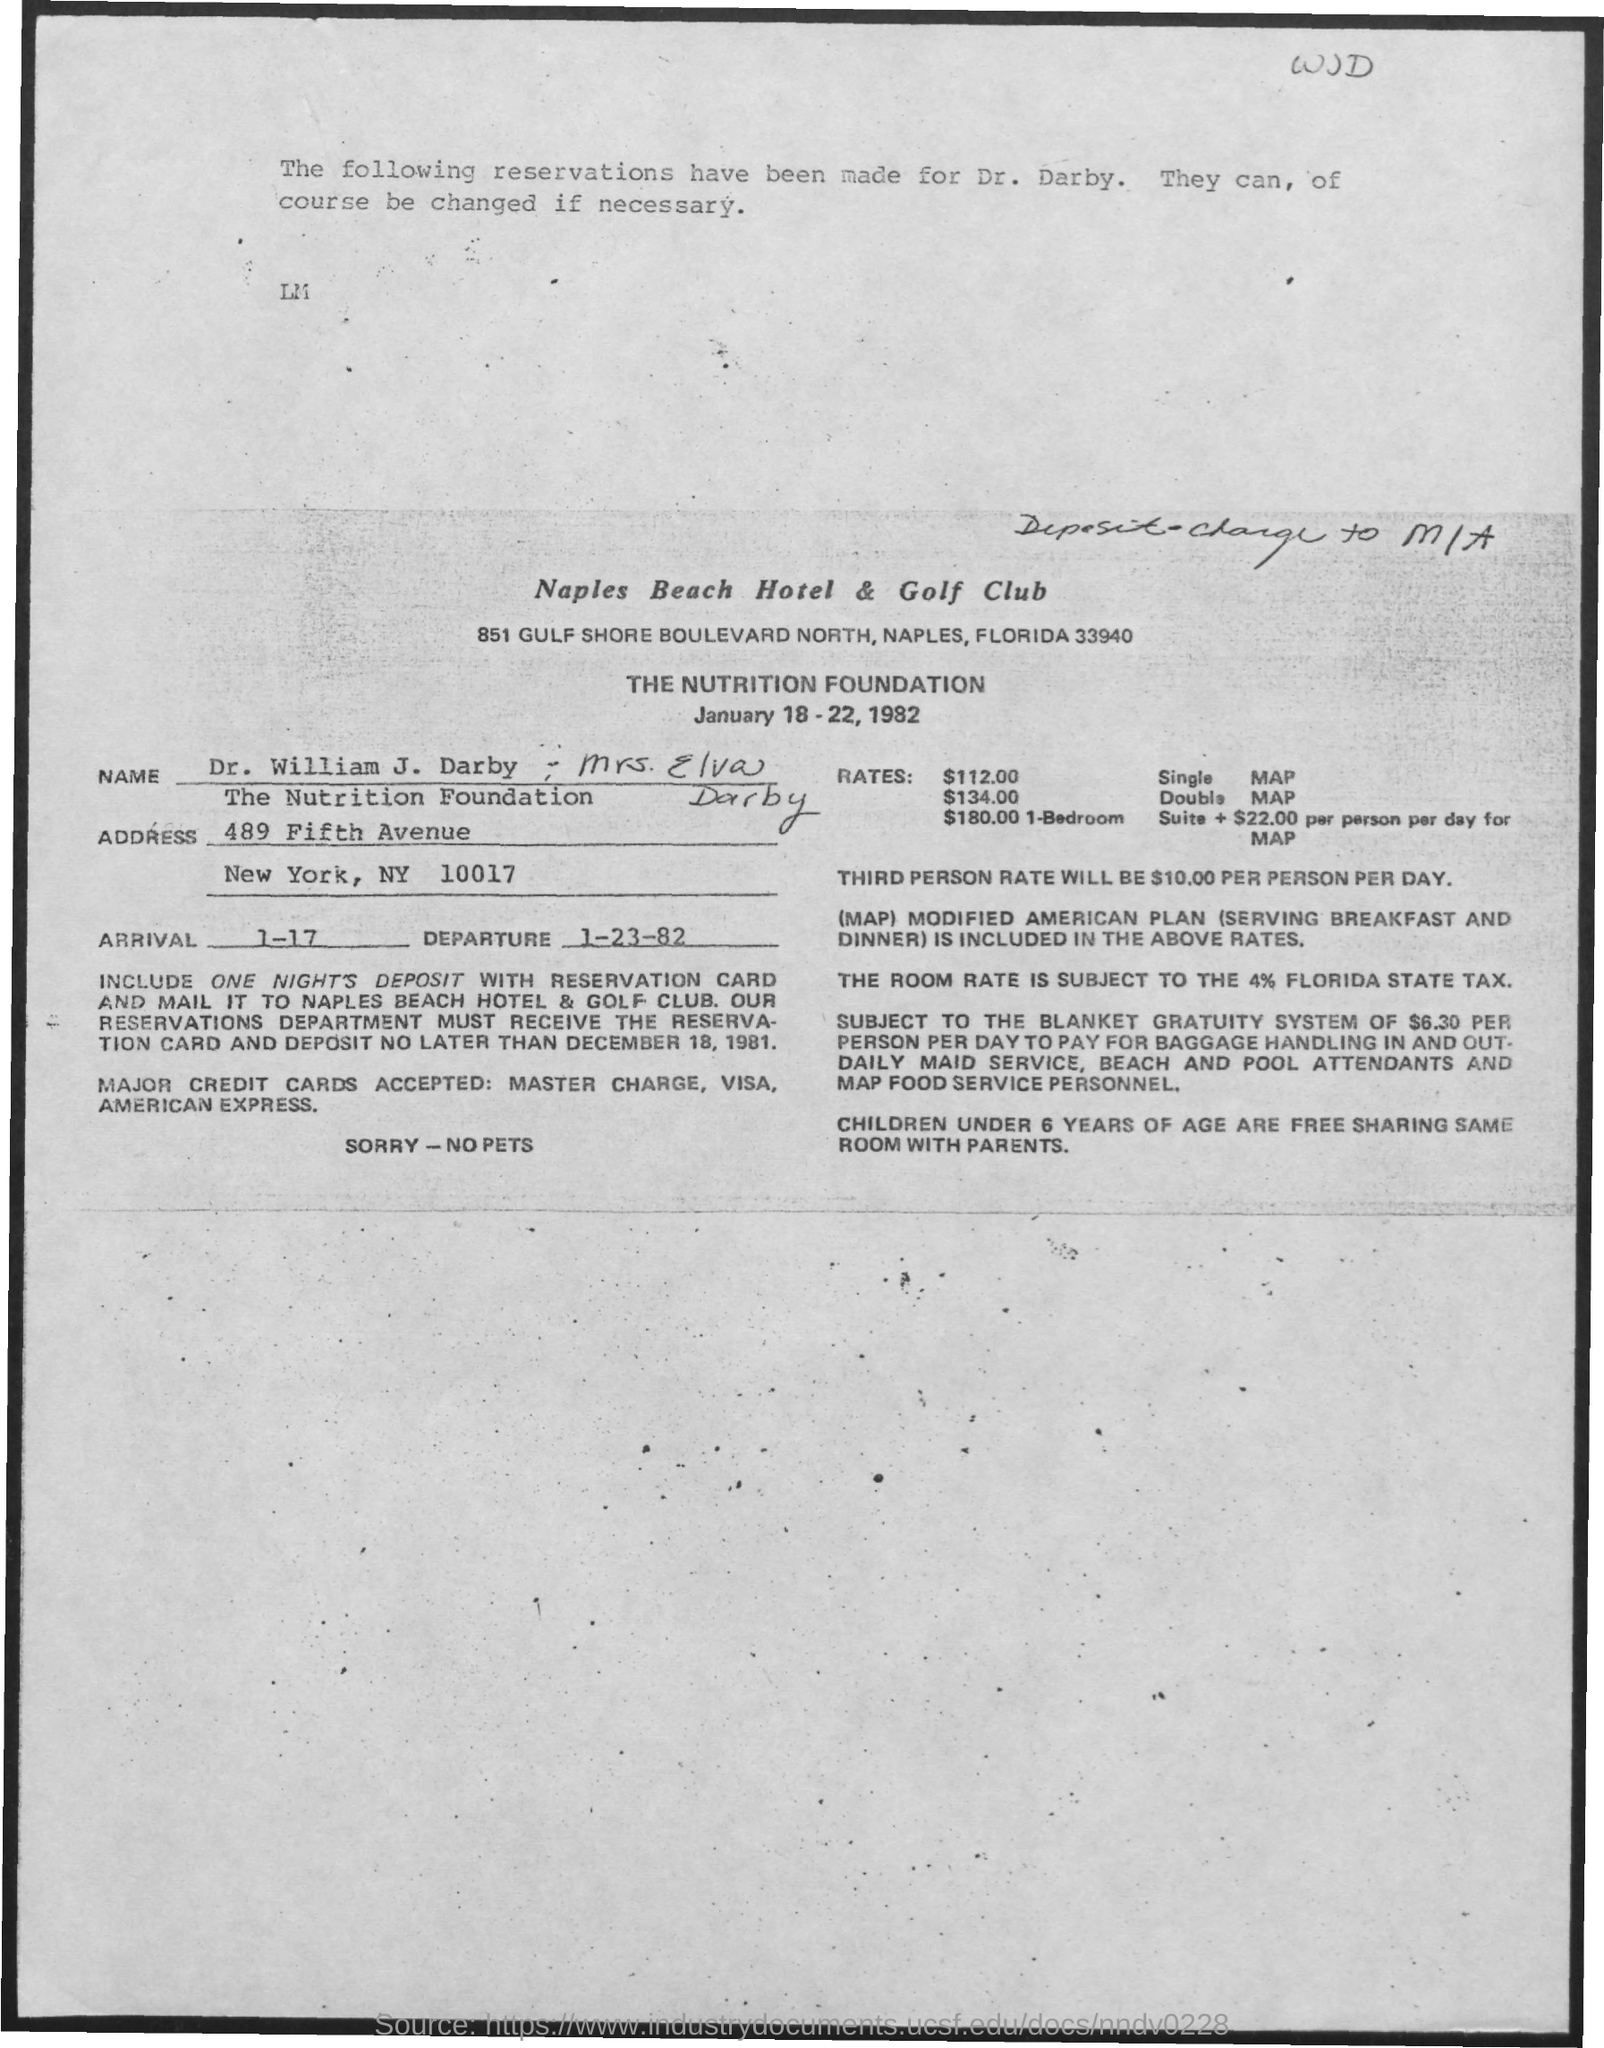Identify some key points in this picture. The name of the hotel where the reservation is done is Naples Beach Hotel & Golf Club. The reservation has been made for Dr. William J. Darby and Mrs. Elva Darby. 